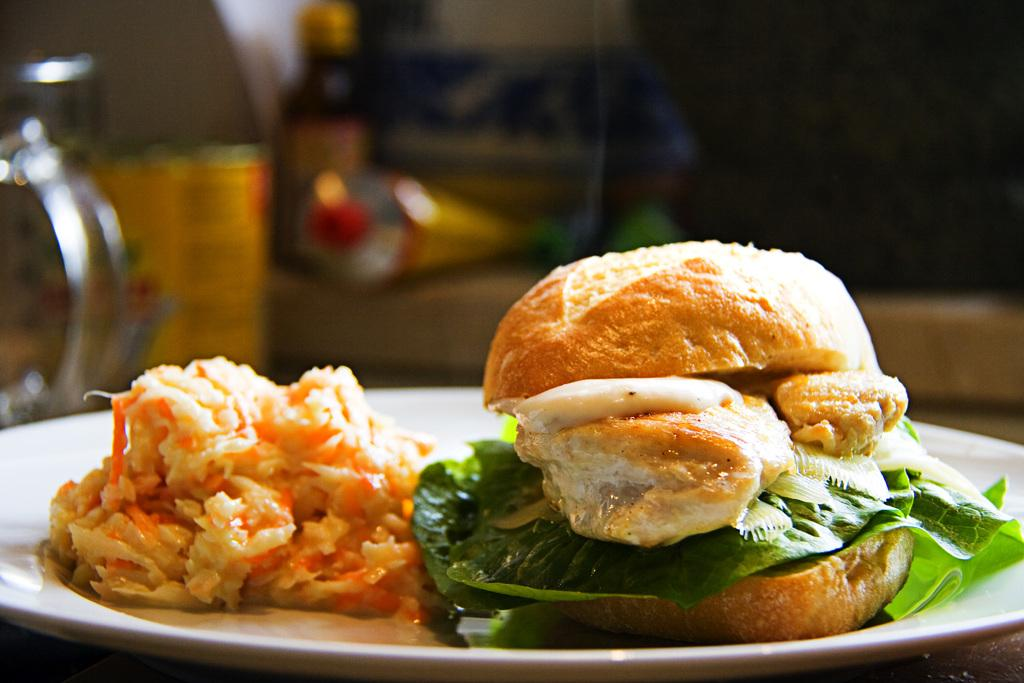What is on the plate that is visible in the image? There is food in a plate in the image. What else can be seen on the table in the image? There is a bottle and a metal box on the table in the image. What type of popcorn is being served in the image? There is no popcorn present in the image. How long has the journey of the food on the plate taken? The facts provided do not give any information about the journey of the food, so it cannot be determined from the image. 